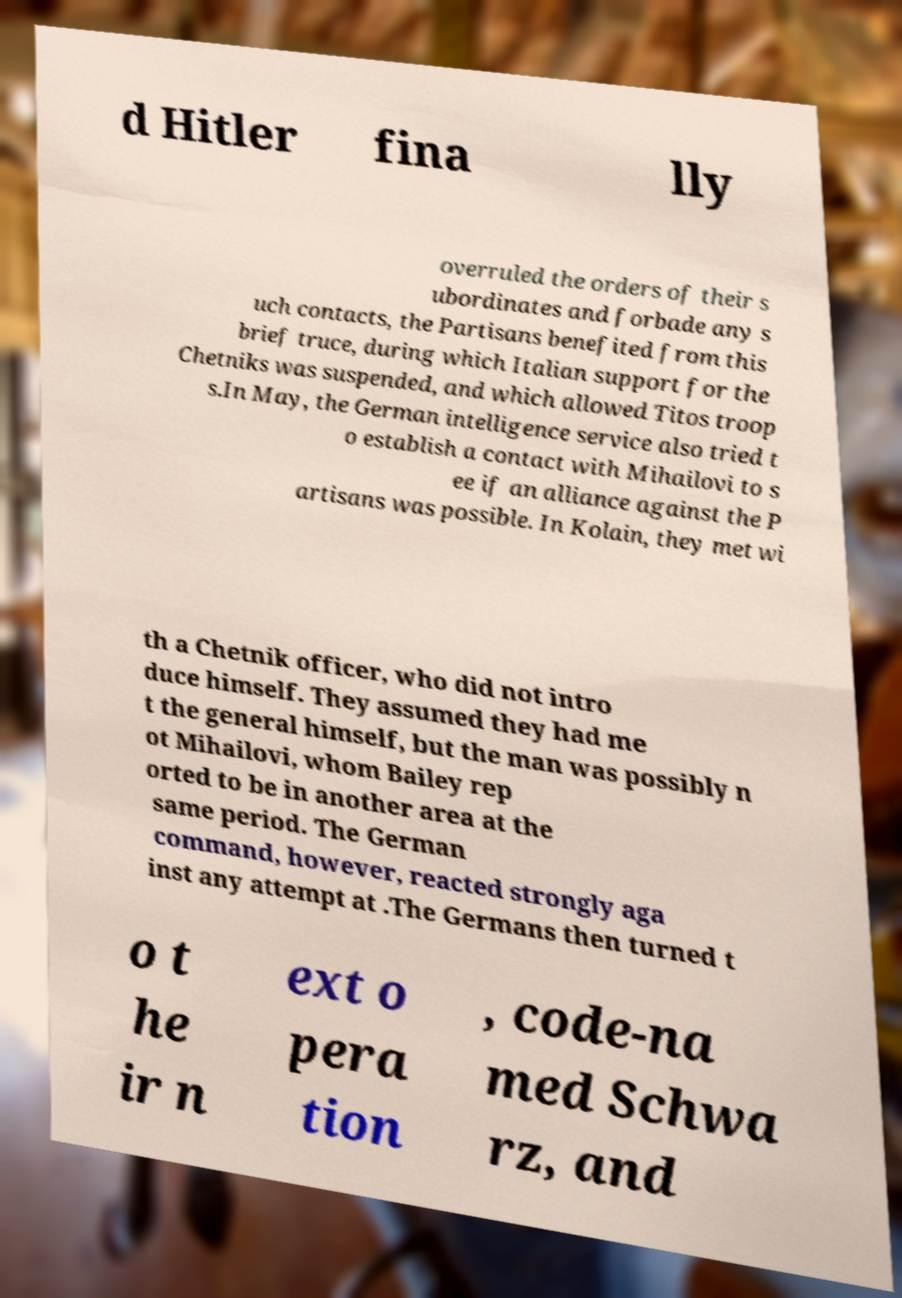Can you read and provide the text displayed in the image?This photo seems to have some interesting text. Can you extract and type it out for me? d Hitler fina lly overruled the orders of their s ubordinates and forbade any s uch contacts, the Partisans benefited from this brief truce, during which Italian support for the Chetniks was suspended, and which allowed Titos troop s.In May, the German intelligence service also tried t o establish a contact with Mihailovi to s ee if an alliance against the P artisans was possible. In Kolain, they met wi th a Chetnik officer, who did not intro duce himself. They assumed they had me t the general himself, but the man was possibly n ot Mihailovi, whom Bailey rep orted to be in another area at the same period. The German command, however, reacted strongly aga inst any attempt at .The Germans then turned t o t he ir n ext o pera tion , code-na med Schwa rz, and 